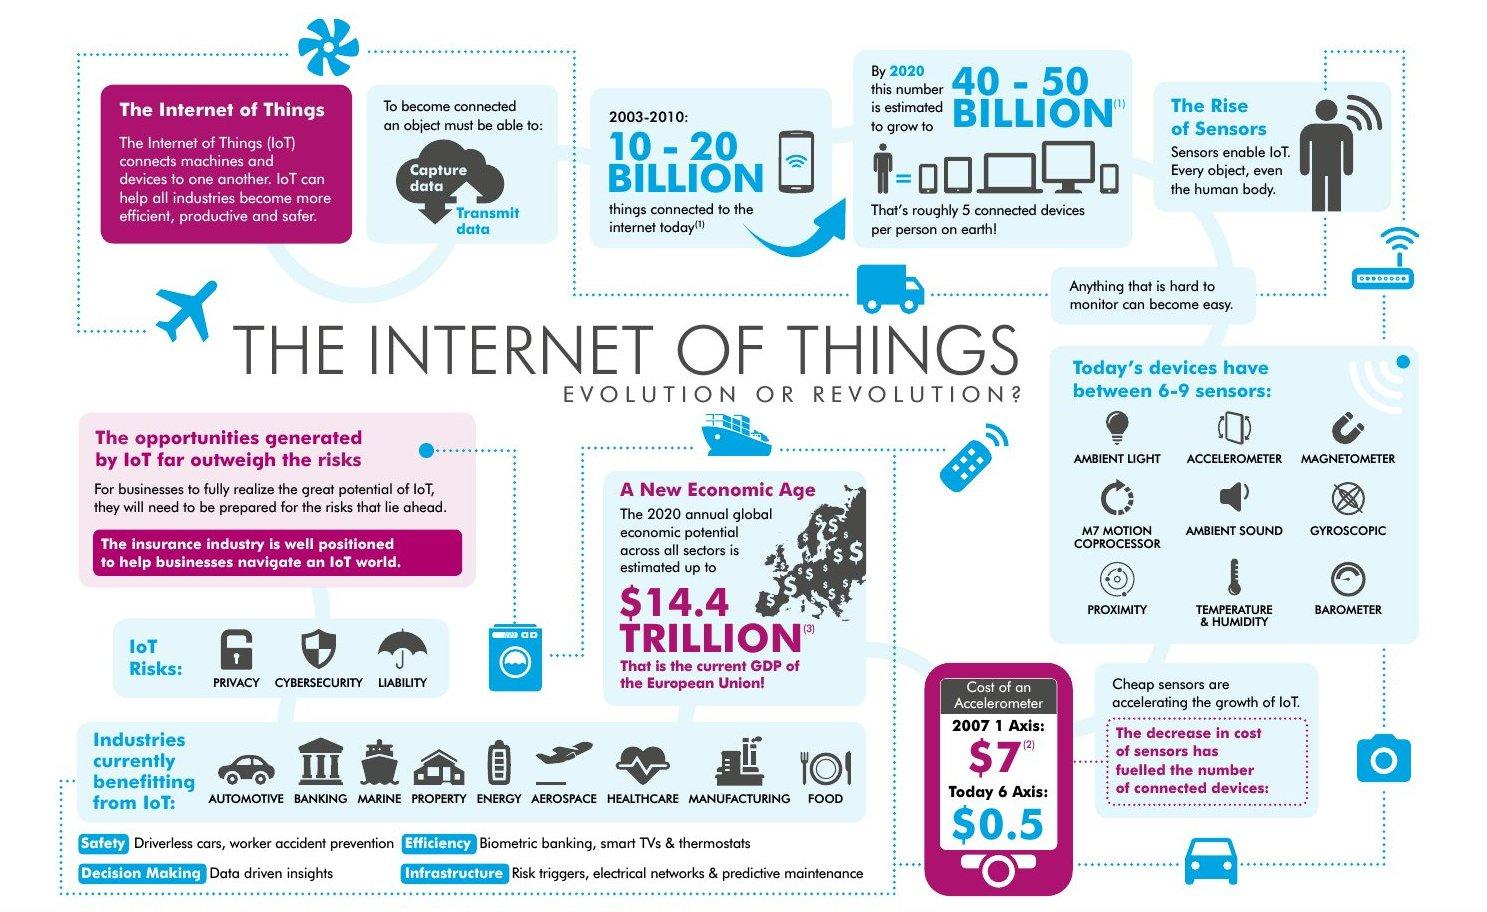List a handful of essential elements in this visual. The infographic lists 3 or 5 risks associated with the internet of things, I'm not sure which one. The Internet of Things is currently benefiting the manufacturing industry, which is the second-to-last industry to experience its advantages. The Internet of Things has been benefiting the aerospace industry, making it the sixth industry to experience its advantages. The Internet of Things is currently benefiting 9 industries, not 6. In the period of seven years from 2003, the number of billion things connected to the internet varied from 10-20 billion to 40-50 billion. 